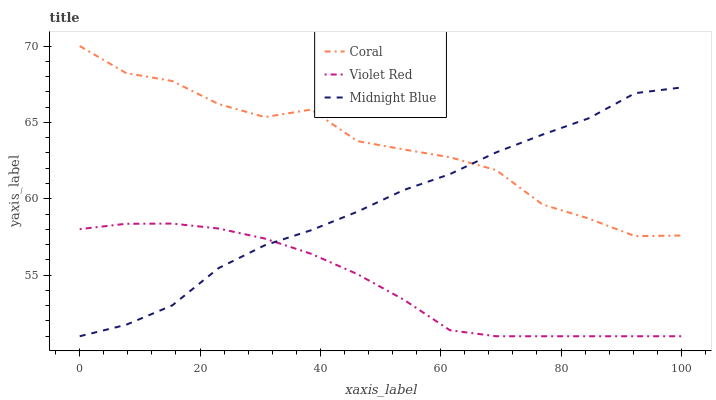Does Violet Red have the minimum area under the curve?
Answer yes or no. Yes. Does Coral have the maximum area under the curve?
Answer yes or no. Yes. Does Midnight Blue have the minimum area under the curve?
Answer yes or no. No. Does Midnight Blue have the maximum area under the curve?
Answer yes or no. No. Is Violet Red the smoothest?
Answer yes or no. Yes. Is Coral the roughest?
Answer yes or no. Yes. Is Midnight Blue the smoothest?
Answer yes or no. No. Is Midnight Blue the roughest?
Answer yes or no. No. Does Violet Red have the lowest value?
Answer yes or no. Yes. Does Coral have the highest value?
Answer yes or no. Yes. Does Midnight Blue have the highest value?
Answer yes or no. No. Is Violet Red less than Coral?
Answer yes or no. Yes. Is Coral greater than Violet Red?
Answer yes or no. Yes. Does Coral intersect Midnight Blue?
Answer yes or no. Yes. Is Coral less than Midnight Blue?
Answer yes or no. No. Is Coral greater than Midnight Blue?
Answer yes or no. No. Does Violet Red intersect Coral?
Answer yes or no. No. 